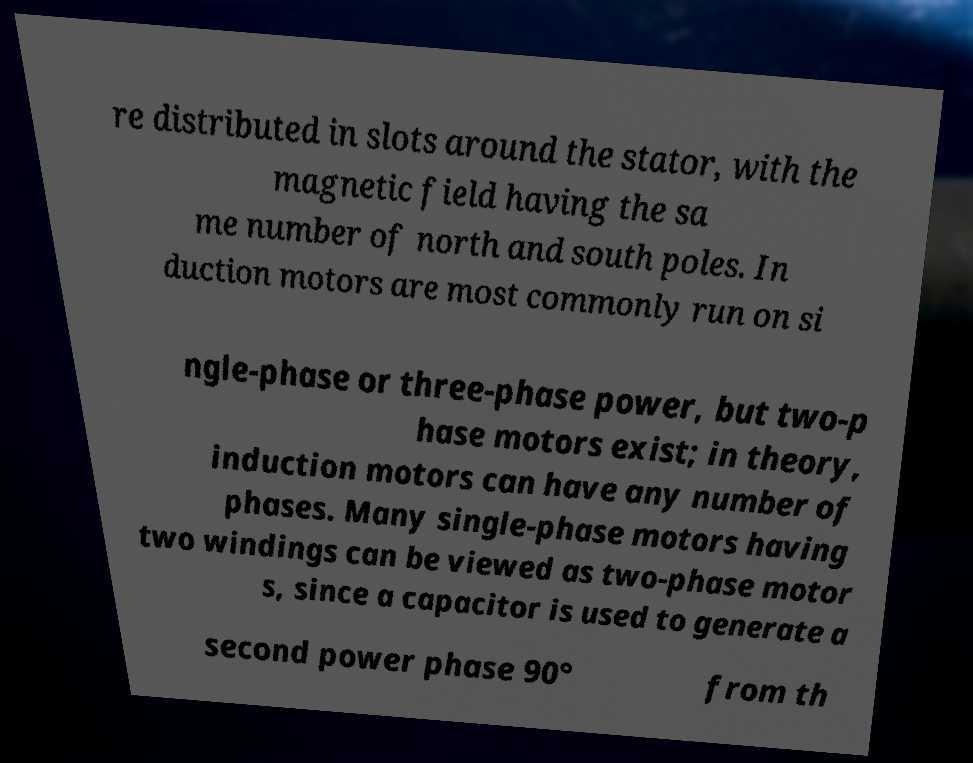For documentation purposes, I need the text within this image transcribed. Could you provide that? re distributed in slots around the stator, with the magnetic field having the sa me number of north and south poles. In duction motors are most commonly run on si ngle-phase or three-phase power, but two-p hase motors exist; in theory, induction motors can have any number of phases. Many single-phase motors having two windings can be viewed as two-phase motor s, since a capacitor is used to generate a second power phase 90° from th 